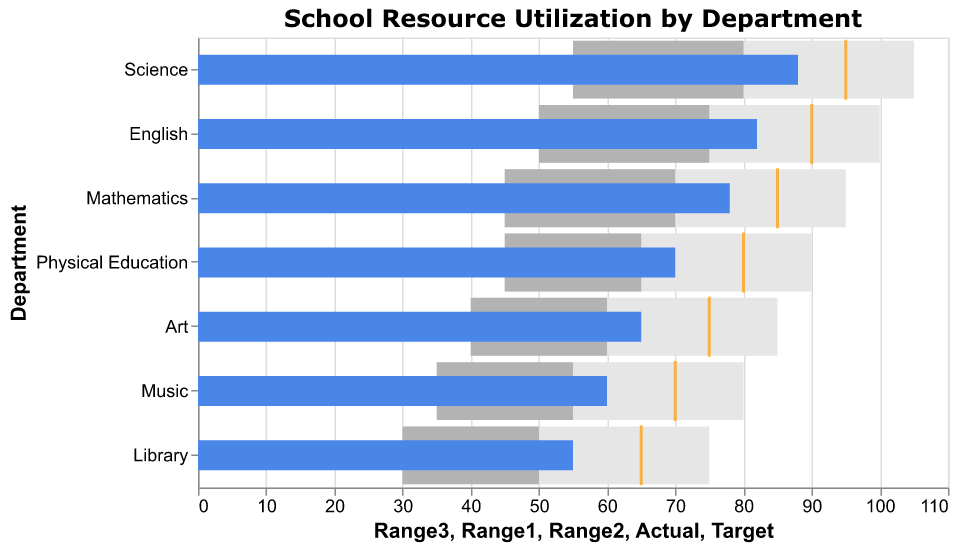What is the title of the chart? The title is typically located at the top of the chart and clearly states what the chart represents.
Answer: School Resource Utilization by Department Which department has the highest actual resource utilization? By examining the length of the blue bars (which indicate actual utilization), the Science department has the longest bar.
Answer: Science What is the actual resource utilization value for the Art department? Locate the blue bar corresponding to the Art department and note its value on the x-axis.
Answer: 65 How much higher is the target utilization compared to actual utilization for the Music department? The Music department's target utilization is 70, and the actual utilization is 60. Subtract the actual from the target: 70 - 60 = 10.
Answer: 10 Which departments exceeded their target utilization? Compare the actual (blue bars) and target (orange ticks) values; if the actual value is greater than or equal to the target value, the department exceeded its target. Only Science exceeded its target of 95 with an actual utilization of 88.
Answer: None What is the range of utilization values for the Mathematics department? The ranges can be determined by looking at the background color bars. Mathematics has three ranges: 45-70, 70-95, and 95-110.
Answer: 45-95 Which department has the lowest target utilization? By looking at the positions of the orange ticks, the department with the furthest left tick has the lowest target. The Library department has the target utilization tick at 65.
Answer: Library What is the average actual utilization for all departments? Sum all the actual values and divide by the total number of departments: (82 + 78 + 88 + 65 + 70 + 60 + 55) / 7 = 71.14.
Answer: 71.14 How does the actual utilization of the Physical Education department compare to the range closest to its target? The Physical Education department has an actual utilization of 70, which falls into the second range (45-65 and 65-90) but is still below the target of 80.
Answer: Below the closest range For which department is the actual utilization closest to the target utilization? Compare the difference between actual and target values for all departments; the English department specifies actual utilization of 82 and target utilization of 90, resulting in a difference of 8.
Answer: English 